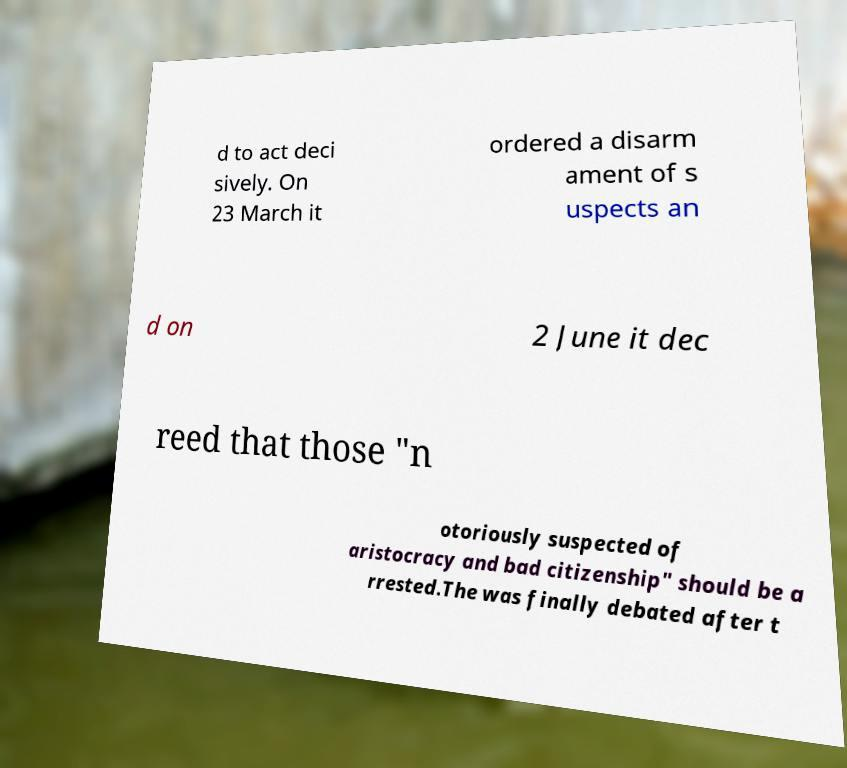For documentation purposes, I need the text within this image transcribed. Could you provide that? d to act deci sively. On 23 March it ordered a disarm ament of s uspects an d on 2 June it dec reed that those "n otoriously suspected of aristocracy and bad citizenship" should be a rrested.The was finally debated after t 